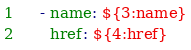Convert code to text. <code><loc_0><loc_0><loc_500><loc_500><_YAML_>    - name: ${3:name}
      href: ${4:href}
</code> 